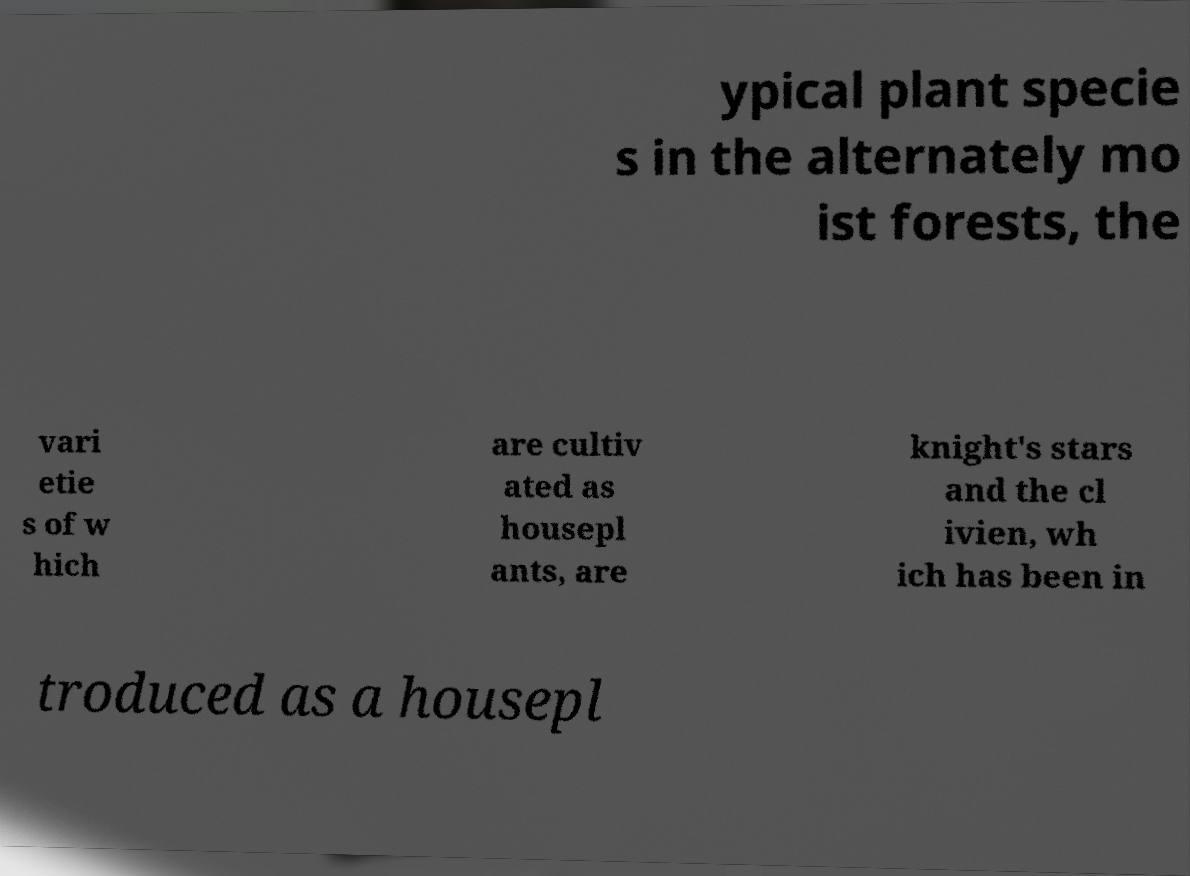I need the written content from this picture converted into text. Can you do that? ypical plant specie s in the alternately mo ist forests, the vari etie s of w hich are cultiv ated as housepl ants, are knight's stars and the cl ivien, wh ich has been in troduced as a housepl 